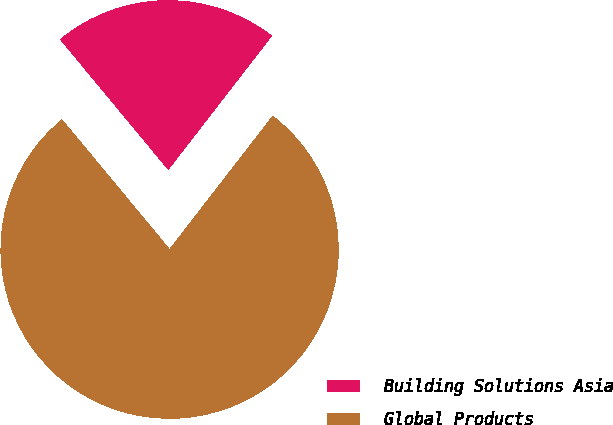Convert chart. <chart><loc_0><loc_0><loc_500><loc_500><pie_chart><fcel>Building Solutions Asia<fcel>Global Products<nl><fcel>21.5%<fcel>78.5%<nl></chart> 